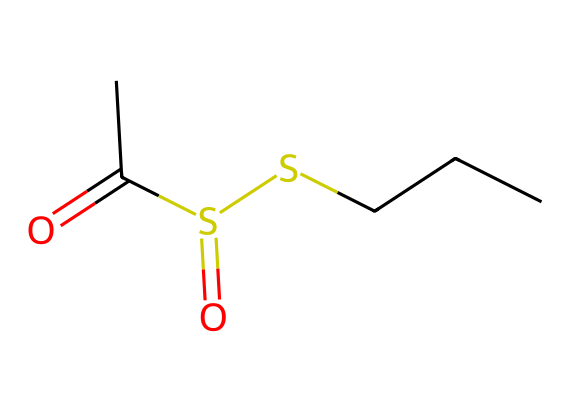What is the molecular formula of this compound? To determine the molecular formula, we count the number of each type of atom present in the SMILES representation. The compound structure includes 5 carbon (C), 10 hydrogen (H), 2 sulfur (S), and 1 oxygen (O). Hence, the molecular formula is C5H10O2S2.
Answer: C5H10O2S2 How many sulfur atoms are present in the molecule? The SMILES representation indicates there are two 'S' symbols, which refer to sulfur atoms. Therefore, we can conclude that there are two sulfur atoms in this structure.
Answer: 2 What type of chemical bonds are present in the structure? By analyzing the SMILES string, we can identify various types of bonds: single bonds (in sulfur and carbon connections), a double bond (in C(=O) for the carbonyl), and a double bond (S(=O) for the sulfonyl). Hence, single and double bonds are present.
Answer: single and double What functional groups are identified in this compound? Analyzing the structure, we can identify a sulfonyl group (–S(=O)–) and a carbonyl group (C=O). Both groups are characteristic of specific functional chemistry that impacts reactivity.
Answer: sulfonyl and carbonyl What is the significance of the sulfonyl group in this compound? The sulfonyl group is known for being highly polar and can engage in strong dipole-dipole interactions, enhancing the compound's solubility in water and biological systems. It also contributes to the compound's biochemical properties.
Answer: enhances polarity and solubility Is this compound considered a thiol? A thiol contains a functional group with a sulfur atom bonded to a hydrogen atom (–SH). This compound does not fit that definition because it contains sulfonamide and carbonyl characteristics instead, lacking the -SH group.
Answer: no What role does allicin play in garlic? Allicin is known for its antimicrobial properties and potential health benefits, including cardiovascular support and antioxidant effects, making it a significant component of garlic's therapeutic effects.
Answer: antimicrobial properties 